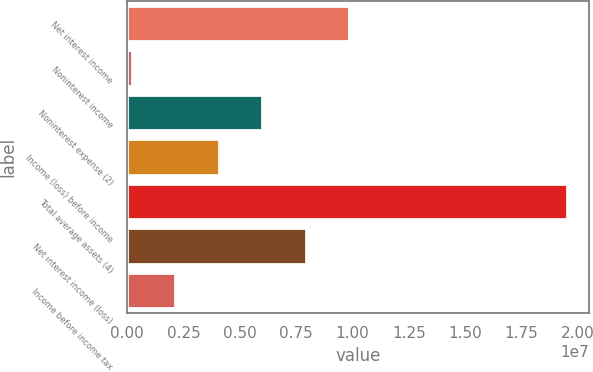Convert chart. <chart><loc_0><loc_0><loc_500><loc_500><bar_chart><fcel>Net interest income<fcel>Noninterest income<fcel>Noninterest expense (2)<fcel>Income (loss) before income<fcel>Total average assets (4)<fcel>Net interest income (loss)<fcel>Income before income tax<nl><fcel>9.85599e+06<fcel>188842<fcel>5.98913e+06<fcel>4.0557e+06<fcel>1.95231e+07<fcel>7.92256e+06<fcel>2.12227e+06<nl></chart> 